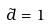<formula> <loc_0><loc_0><loc_500><loc_500>\tilde { d } = 1</formula> 